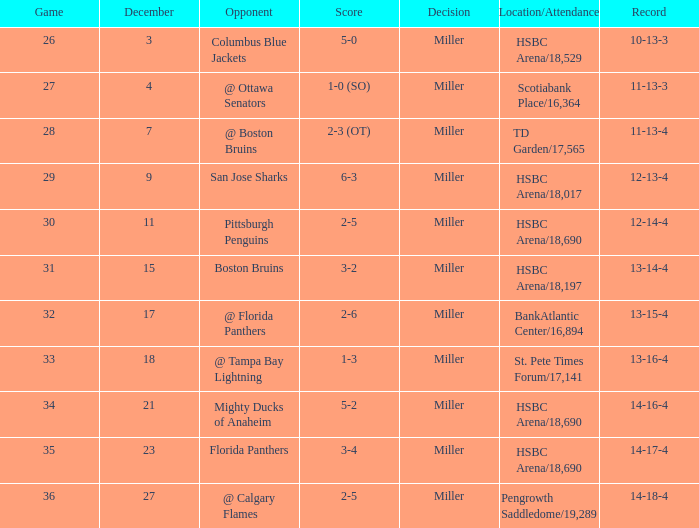Who is the rival having a 10-13-3 score? Columbus Blue Jackets. 